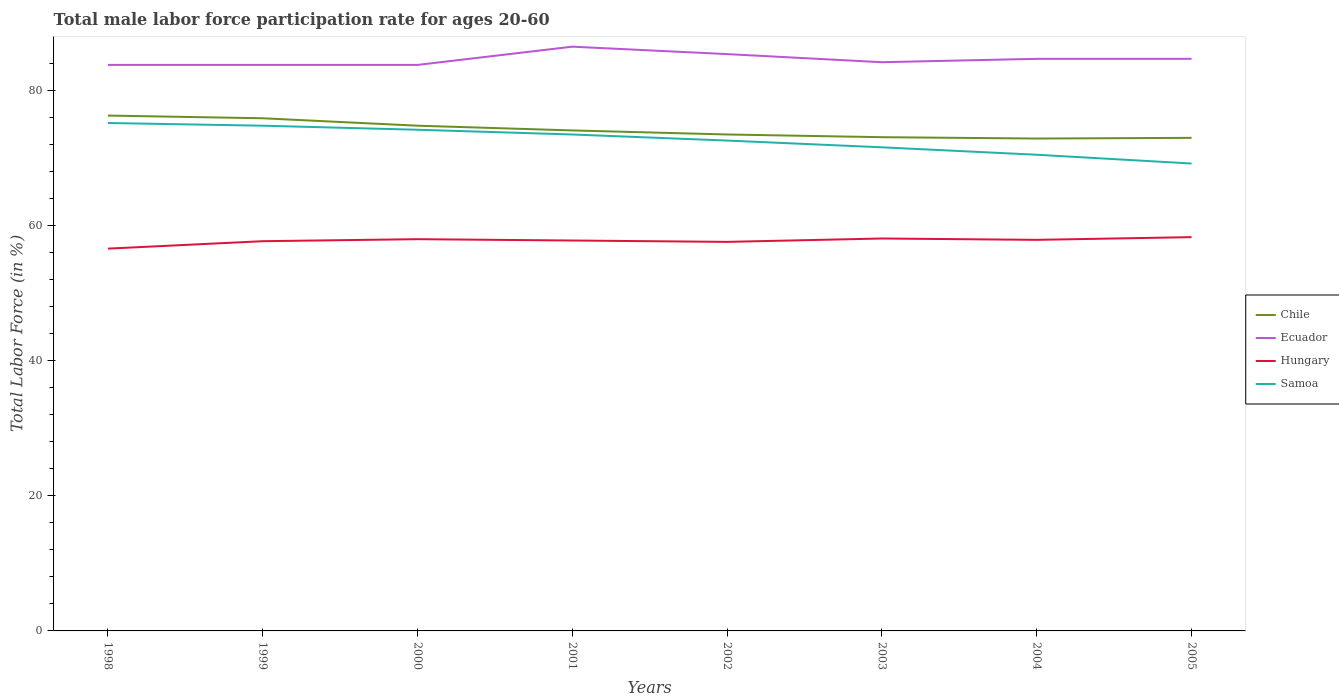Across all years, what is the maximum male labor force participation rate in Chile?
Your response must be concise. 72.9. What is the total male labor force participation rate in Chile in the graph?
Ensure brevity in your answer.  0.6. What is the difference between the highest and the second highest male labor force participation rate in Ecuador?
Ensure brevity in your answer.  2.7. Is the male labor force participation rate in Chile strictly greater than the male labor force participation rate in Hungary over the years?
Keep it short and to the point. No. How many years are there in the graph?
Ensure brevity in your answer.  8. What is the difference between two consecutive major ticks on the Y-axis?
Your response must be concise. 20. Are the values on the major ticks of Y-axis written in scientific E-notation?
Ensure brevity in your answer.  No. Does the graph contain grids?
Your answer should be compact. No. Where does the legend appear in the graph?
Keep it short and to the point. Center right. What is the title of the graph?
Give a very brief answer. Total male labor force participation rate for ages 20-60. Does "Chad" appear as one of the legend labels in the graph?
Offer a terse response. No. What is the label or title of the X-axis?
Make the answer very short. Years. What is the Total Labor Force (in %) of Chile in 1998?
Keep it short and to the point. 76.3. What is the Total Labor Force (in %) of Ecuador in 1998?
Make the answer very short. 83.8. What is the Total Labor Force (in %) of Hungary in 1998?
Offer a very short reply. 56.6. What is the Total Labor Force (in %) of Samoa in 1998?
Keep it short and to the point. 75.2. What is the Total Labor Force (in %) in Chile in 1999?
Provide a short and direct response. 75.9. What is the Total Labor Force (in %) of Ecuador in 1999?
Your answer should be very brief. 83.8. What is the Total Labor Force (in %) of Hungary in 1999?
Offer a terse response. 57.7. What is the Total Labor Force (in %) of Samoa in 1999?
Offer a very short reply. 74.8. What is the Total Labor Force (in %) in Chile in 2000?
Give a very brief answer. 74.8. What is the Total Labor Force (in %) in Ecuador in 2000?
Make the answer very short. 83.8. What is the Total Labor Force (in %) of Hungary in 2000?
Your answer should be very brief. 58. What is the Total Labor Force (in %) in Samoa in 2000?
Make the answer very short. 74.2. What is the Total Labor Force (in %) of Chile in 2001?
Provide a short and direct response. 74.1. What is the Total Labor Force (in %) of Ecuador in 2001?
Make the answer very short. 86.5. What is the Total Labor Force (in %) of Hungary in 2001?
Provide a succinct answer. 57.8. What is the Total Labor Force (in %) in Samoa in 2001?
Provide a short and direct response. 73.5. What is the Total Labor Force (in %) in Chile in 2002?
Provide a short and direct response. 73.5. What is the Total Labor Force (in %) in Ecuador in 2002?
Keep it short and to the point. 85.4. What is the Total Labor Force (in %) of Hungary in 2002?
Keep it short and to the point. 57.6. What is the Total Labor Force (in %) in Samoa in 2002?
Your response must be concise. 72.6. What is the Total Labor Force (in %) of Chile in 2003?
Offer a very short reply. 73.1. What is the Total Labor Force (in %) of Ecuador in 2003?
Ensure brevity in your answer.  84.2. What is the Total Labor Force (in %) in Hungary in 2003?
Offer a terse response. 58.1. What is the Total Labor Force (in %) of Samoa in 2003?
Ensure brevity in your answer.  71.6. What is the Total Labor Force (in %) in Chile in 2004?
Your answer should be compact. 72.9. What is the Total Labor Force (in %) in Ecuador in 2004?
Ensure brevity in your answer.  84.7. What is the Total Labor Force (in %) in Hungary in 2004?
Give a very brief answer. 57.9. What is the Total Labor Force (in %) in Samoa in 2004?
Keep it short and to the point. 70.5. What is the Total Labor Force (in %) of Chile in 2005?
Your response must be concise. 73. What is the Total Labor Force (in %) in Ecuador in 2005?
Provide a succinct answer. 84.7. What is the Total Labor Force (in %) of Hungary in 2005?
Keep it short and to the point. 58.3. What is the Total Labor Force (in %) of Samoa in 2005?
Your response must be concise. 69.2. Across all years, what is the maximum Total Labor Force (in %) in Chile?
Provide a succinct answer. 76.3. Across all years, what is the maximum Total Labor Force (in %) of Ecuador?
Your response must be concise. 86.5. Across all years, what is the maximum Total Labor Force (in %) in Hungary?
Give a very brief answer. 58.3. Across all years, what is the maximum Total Labor Force (in %) in Samoa?
Offer a very short reply. 75.2. Across all years, what is the minimum Total Labor Force (in %) of Chile?
Offer a terse response. 72.9. Across all years, what is the minimum Total Labor Force (in %) of Ecuador?
Offer a terse response. 83.8. Across all years, what is the minimum Total Labor Force (in %) in Hungary?
Offer a very short reply. 56.6. Across all years, what is the minimum Total Labor Force (in %) in Samoa?
Ensure brevity in your answer.  69.2. What is the total Total Labor Force (in %) of Chile in the graph?
Your answer should be very brief. 593.6. What is the total Total Labor Force (in %) of Ecuador in the graph?
Make the answer very short. 676.9. What is the total Total Labor Force (in %) of Hungary in the graph?
Ensure brevity in your answer.  462. What is the total Total Labor Force (in %) in Samoa in the graph?
Provide a succinct answer. 581.6. What is the difference between the Total Labor Force (in %) in Chile in 1998 and that in 1999?
Ensure brevity in your answer.  0.4. What is the difference between the Total Labor Force (in %) of Ecuador in 1998 and that in 1999?
Provide a short and direct response. 0. What is the difference between the Total Labor Force (in %) in Hungary in 1998 and that in 1999?
Provide a short and direct response. -1.1. What is the difference between the Total Labor Force (in %) of Samoa in 1998 and that in 1999?
Keep it short and to the point. 0.4. What is the difference between the Total Labor Force (in %) of Hungary in 1998 and that in 2000?
Provide a short and direct response. -1.4. What is the difference between the Total Labor Force (in %) in Samoa in 1998 and that in 2000?
Ensure brevity in your answer.  1. What is the difference between the Total Labor Force (in %) in Hungary in 1998 and that in 2002?
Your answer should be compact. -1. What is the difference between the Total Labor Force (in %) of Ecuador in 1998 and that in 2003?
Keep it short and to the point. -0.4. What is the difference between the Total Labor Force (in %) of Samoa in 1998 and that in 2003?
Make the answer very short. 3.6. What is the difference between the Total Labor Force (in %) in Chile in 1998 and that in 2004?
Make the answer very short. 3.4. What is the difference between the Total Labor Force (in %) in Hungary in 1998 and that in 2004?
Offer a terse response. -1.3. What is the difference between the Total Labor Force (in %) in Chile in 1998 and that in 2005?
Give a very brief answer. 3.3. What is the difference between the Total Labor Force (in %) in Ecuador in 1998 and that in 2005?
Give a very brief answer. -0.9. What is the difference between the Total Labor Force (in %) of Samoa in 1998 and that in 2005?
Provide a succinct answer. 6. What is the difference between the Total Labor Force (in %) in Ecuador in 1999 and that in 2000?
Offer a very short reply. 0. What is the difference between the Total Labor Force (in %) in Hungary in 1999 and that in 2000?
Your answer should be very brief. -0.3. What is the difference between the Total Labor Force (in %) of Samoa in 1999 and that in 2000?
Ensure brevity in your answer.  0.6. What is the difference between the Total Labor Force (in %) of Ecuador in 1999 and that in 2001?
Your answer should be very brief. -2.7. What is the difference between the Total Labor Force (in %) in Hungary in 1999 and that in 2001?
Your answer should be compact. -0.1. What is the difference between the Total Labor Force (in %) in Samoa in 1999 and that in 2001?
Offer a terse response. 1.3. What is the difference between the Total Labor Force (in %) in Chile in 1999 and that in 2002?
Your answer should be very brief. 2.4. What is the difference between the Total Labor Force (in %) in Ecuador in 1999 and that in 2002?
Make the answer very short. -1.6. What is the difference between the Total Labor Force (in %) in Samoa in 1999 and that in 2002?
Provide a succinct answer. 2.2. What is the difference between the Total Labor Force (in %) in Samoa in 1999 and that in 2003?
Give a very brief answer. 3.2. What is the difference between the Total Labor Force (in %) of Ecuador in 1999 and that in 2004?
Offer a terse response. -0.9. What is the difference between the Total Labor Force (in %) in Samoa in 1999 and that in 2004?
Provide a short and direct response. 4.3. What is the difference between the Total Labor Force (in %) of Chile in 1999 and that in 2005?
Your response must be concise. 2.9. What is the difference between the Total Labor Force (in %) of Ecuador in 1999 and that in 2005?
Offer a terse response. -0.9. What is the difference between the Total Labor Force (in %) in Samoa in 1999 and that in 2005?
Ensure brevity in your answer.  5.6. What is the difference between the Total Labor Force (in %) in Samoa in 2000 and that in 2001?
Your response must be concise. 0.7. What is the difference between the Total Labor Force (in %) in Chile in 2000 and that in 2002?
Your answer should be very brief. 1.3. What is the difference between the Total Labor Force (in %) in Ecuador in 2000 and that in 2002?
Offer a terse response. -1.6. What is the difference between the Total Labor Force (in %) in Samoa in 2000 and that in 2002?
Provide a short and direct response. 1.6. What is the difference between the Total Labor Force (in %) of Hungary in 2000 and that in 2003?
Your response must be concise. -0.1. What is the difference between the Total Labor Force (in %) in Samoa in 2000 and that in 2003?
Make the answer very short. 2.6. What is the difference between the Total Labor Force (in %) in Chile in 2000 and that in 2004?
Your answer should be compact. 1.9. What is the difference between the Total Labor Force (in %) of Hungary in 2000 and that in 2004?
Your answer should be very brief. 0.1. What is the difference between the Total Labor Force (in %) of Chile in 2000 and that in 2005?
Ensure brevity in your answer.  1.8. What is the difference between the Total Labor Force (in %) of Hungary in 2000 and that in 2005?
Ensure brevity in your answer.  -0.3. What is the difference between the Total Labor Force (in %) in Samoa in 2000 and that in 2005?
Give a very brief answer. 5. What is the difference between the Total Labor Force (in %) in Chile in 2001 and that in 2002?
Give a very brief answer. 0.6. What is the difference between the Total Labor Force (in %) of Hungary in 2001 and that in 2002?
Give a very brief answer. 0.2. What is the difference between the Total Labor Force (in %) of Ecuador in 2001 and that in 2003?
Your response must be concise. 2.3. What is the difference between the Total Labor Force (in %) in Samoa in 2001 and that in 2003?
Provide a succinct answer. 1.9. What is the difference between the Total Labor Force (in %) in Chile in 2001 and that in 2005?
Your answer should be compact. 1.1. What is the difference between the Total Labor Force (in %) in Ecuador in 2001 and that in 2005?
Your answer should be compact. 1.8. What is the difference between the Total Labor Force (in %) in Chile in 2002 and that in 2003?
Make the answer very short. 0.4. What is the difference between the Total Labor Force (in %) in Ecuador in 2002 and that in 2003?
Provide a short and direct response. 1.2. What is the difference between the Total Labor Force (in %) of Hungary in 2002 and that in 2003?
Provide a short and direct response. -0.5. What is the difference between the Total Labor Force (in %) in Hungary in 2002 and that in 2004?
Provide a short and direct response. -0.3. What is the difference between the Total Labor Force (in %) in Samoa in 2002 and that in 2004?
Offer a terse response. 2.1. What is the difference between the Total Labor Force (in %) of Ecuador in 2002 and that in 2005?
Your answer should be very brief. 0.7. What is the difference between the Total Labor Force (in %) in Samoa in 2002 and that in 2005?
Provide a succinct answer. 3.4. What is the difference between the Total Labor Force (in %) of Chile in 2003 and that in 2004?
Make the answer very short. 0.2. What is the difference between the Total Labor Force (in %) of Samoa in 2003 and that in 2004?
Offer a terse response. 1.1. What is the difference between the Total Labor Force (in %) of Hungary in 2003 and that in 2005?
Make the answer very short. -0.2. What is the difference between the Total Labor Force (in %) of Samoa in 2003 and that in 2005?
Your answer should be compact. 2.4. What is the difference between the Total Labor Force (in %) of Hungary in 2004 and that in 2005?
Provide a succinct answer. -0.4. What is the difference between the Total Labor Force (in %) in Chile in 1998 and the Total Labor Force (in %) in Hungary in 1999?
Make the answer very short. 18.6. What is the difference between the Total Labor Force (in %) in Chile in 1998 and the Total Labor Force (in %) in Samoa in 1999?
Offer a terse response. 1.5. What is the difference between the Total Labor Force (in %) in Ecuador in 1998 and the Total Labor Force (in %) in Hungary in 1999?
Provide a short and direct response. 26.1. What is the difference between the Total Labor Force (in %) in Ecuador in 1998 and the Total Labor Force (in %) in Samoa in 1999?
Provide a short and direct response. 9. What is the difference between the Total Labor Force (in %) in Hungary in 1998 and the Total Labor Force (in %) in Samoa in 1999?
Make the answer very short. -18.2. What is the difference between the Total Labor Force (in %) in Chile in 1998 and the Total Labor Force (in %) in Hungary in 2000?
Your response must be concise. 18.3. What is the difference between the Total Labor Force (in %) of Chile in 1998 and the Total Labor Force (in %) of Samoa in 2000?
Your answer should be very brief. 2.1. What is the difference between the Total Labor Force (in %) of Ecuador in 1998 and the Total Labor Force (in %) of Hungary in 2000?
Ensure brevity in your answer.  25.8. What is the difference between the Total Labor Force (in %) in Hungary in 1998 and the Total Labor Force (in %) in Samoa in 2000?
Offer a very short reply. -17.6. What is the difference between the Total Labor Force (in %) of Chile in 1998 and the Total Labor Force (in %) of Hungary in 2001?
Your answer should be compact. 18.5. What is the difference between the Total Labor Force (in %) of Hungary in 1998 and the Total Labor Force (in %) of Samoa in 2001?
Keep it short and to the point. -16.9. What is the difference between the Total Labor Force (in %) of Chile in 1998 and the Total Labor Force (in %) of Ecuador in 2002?
Offer a terse response. -9.1. What is the difference between the Total Labor Force (in %) in Chile in 1998 and the Total Labor Force (in %) in Samoa in 2002?
Provide a short and direct response. 3.7. What is the difference between the Total Labor Force (in %) in Ecuador in 1998 and the Total Labor Force (in %) in Hungary in 2002?
Make the answer very short. 26.2. What is the difference between the Total Labor Force (in %) in Ecuador in 1998 and the Total Labor Force (in %) in Samoa in 2002?
Offer a very short reply. 11.2. What is the difference between the Total Labor Force (in %) of Hungary in 1998 and the Total Labor Force (in %) of Samoa in 2002?
Offer a very short reply. -16. What is the difference between the Total Labor Force (in %) of Chile in 1998 and the Total Labor Force (in %) of Samoa in 2003?
Provide a succinct answer. 4.7. What is the difference between the Total Labor Force (in %) in Ecuador in 1998 and the Total Labor Force (in %) in Hungary in 2003?
Make the answer very short. 25.7. What is the difference between the Total Labor Force (in %) in Chile in 1998 and the Total Labor Force (in %) in Hungary in 2004?
Keep it short and to the point. 18.4. What is the difference between the Total Labor Force (in %) in Ecuador in 1998 and the Total Labor Force (in %) in Hungary in 2004?
Ensure brevity in your answer.  25.9. What is the difference between the Total Labor Force (in %) of Hungary in 1998 and the Total Labor Force (in %) of Samoa in 2004?
Provide a succinct answer. -13.9. What is the difference between the Total Labor Force (in %) of Chile in 1998 and the Total Labor Force (in %) of Ecuador in 2005?
Offer a terse response. -8.4. What is the difference between the Total Labor Force (in %) of Chile in 1998 and the Total Labor Force (in %) of Hungary in 2005?
Provide a succinct answer. 18. What is the difference between the Total Labor Force (in %) of Chile in 1998 and the Total Labor Force (in %) of Samoa in 2005?
Give a very brief answer. 7.1. What is the difference between the Total Labor Force (in %) of Hungary in 1998 and the Total Labor Force (in %) of Samoa in 2005?
Make the answer very short. -12.6. What is the difference between the Total Labor Force (in %) in Chile in 1999 and the Total Labor Force (in %) in Ecuador in 2000?
Provide a short and direct response. -7.9. What is the difference between the Total Labor Force (in %) in Chile in 1999 and the Total Labor Force (in %) in Hungary in 2000?
Offer a very short reply. 17.9. What is the difference between the Total Labor Force (in %) of Chile in 1999 and the Total Labor Force (in %) of Samoa in 2000?
Your response must be concise. 1.7. What is the difference between the Total Labor Force (in %) in Ecuador in 1999 and the Total Labor Force (in %) in Hungary in 2000?
Your answer should be compact. 25.8. What is the difference between the Total Labor Force (in %) in Hungary in 1999 and the Total Labor Force (in %) in Samoa in 2000?
Your response must be concise. -16.5. What is the difference between the Total Labor Force (in %) of Chile in 1999 and the Total Labor Force (in %) of Ecuador in 2001?
Keep it short and to the point. -10.6. What is the difference between the Total Labor Force (in %) of Chile in 1999 and the Total Labor Force (in %) of Hungary in 2001?
Keep it short and to the point. 18.1. What is the difference between the Total Labor Force (in %) in Chile in 1999 and the Total Labor Force (in %) in Samoa in 2001?
Offer a very short reply. 2.4. What is the difference between the Total Labor Force (in %) in Hungary in 1999 and the Total Labor Force (in %) in Samoa in 2001?
Make the answer very short. -15.8. What is the difference between the Total Labor Force (in %) in Ecuador in 1999 and the Total Labor Force (in %) in Hungary in 2002?
Keep it short and to the point. 26.2. What is the difference between the Total Labor Force (in %) in Ecuador in 1999 and the Total Labor Force (in %) in Samoa in 2002?
Offer a terse response. 11.2. What is the difference between the Total Labor Force (in %) in Hungary in 1999 and the Total Labor Force (in %) in Samoa in 2002?
Provide a short and direct response. -14.9. What is the difference between the Total Labor Force (in %) in Chile in 1999 and the Total Labor Force (in %) in Samoa in 2003?
Your answer should be compact. 4.3. What is the difference between the Total Labor Force (in %) in Ecuador in 1999 and the Total Labor Force (in %) in Hungary in 2003?
Provide a succinct answer. 25.7. What is the difference between the Total Labor Force (in %) in Chile in 1999 and the Total Labor Force (in %) in Hungary in 2004?
Ensure brevity in your answer.  18. What is the difference between the Total Labor Force (in %) in Ecuador in 1999 and the Total Labor Force (in %) in Hungary in 2004?
Provide a succinct answer. 25.9. What is the difference between the Total Labor Force (in %) in Chile in 1999 and the Total Labor Force (in %) in Hungary in 2005?
Make the answer very short. 17.6. What is the difference between the Total Labor Force (in %) of Chile in 2000 and the Total Labor Force (in %) of Hungary in 2001?
Your response must be concise. 17. What is the difference between the Total Labor Force (in %) in Chile in 2000 and the Total Labor Force (in %) in Samoa in 2001?
Make the answer very short. 1.3. What is the difference between the Total Labor Force (in %) in Ecuador in 2000 and the Total Labor Force (in %) in Hungary in 2001?
Keep it short and to the point. 26. What is the difference between the Total Labor Force (in %) in Hungary in 2000 and the Total Labor Force (in %) in Samoa in 2001?
Make the answer very short. -15.5. What is the difference between the Total Labor Force (in %) of Chile in 2000 and the Total Labor Force (in %) of Hungary in 2002?
Offer a terse response. 17.2. What is the difference between the Total Labor Force (in %) of Ecuador in 2000 and the Total Labor Force (in %) of Hungary in 2002?
Offer a terse response. 26.2. What is the difference between the Total Labor Force (in %) of Ecuador in 2000 and the Total Labor Force (in %) of Samoa in 2002?
Your response must be concise. 11.2. What is the difference between the Total Labor Force (in %) of Hungary in 2000 and the Total Labor Force (in %) of Samoa in 2002?
Your answer should be compact. -14.6. What is the difference between the Total Labor Force (in %) of Chile in 2000 and the Total Labor Force (in %) of Hungary in 2003?
Give a very brief answer. 16.7. What is the difference between the Total Labor Force (in %) of Ecuador in 2000 and the Total Labor Force (in %) of Hungary in 2003?
Give a very brief answer. 25.7. What is the difference between the Total Labor Force (in %) of Chile in 2000 and the Total Labor Force (in %) of Samoa in 2004?
Provide a short and direct response. 4.3. What is the difference between the Total Labor Force (in %) in Ecuador in 2000 and the Total Labor Force (in %) in Hungary in 2004?
Provide a succinct answer. 25.9. What is the difference between the Total Labor Force (in %) of Chile in 2000 and the Total Labor Force (in %) of Ecuador in 2005?
Ensure brevity in your answer.  -9.9. What is the difference between the Total Labor Force (in %) of Chile in 2000 and the Total Labor Force (in %) of Samoa in 2005?
Provide a short and direct response. 5.6. What is the difference between the Total Labor Force (in %) of Ecuador in 2000 and the Total Labor Force (in %) of Samoa in 2005?
Make the answer very short. 14.6. What is the difference between the Total Labor Force (in %) in Chile in 2001 and the Total Labor Force (in %) in Hungary in 2002?
Offer a very short reply. 16.5. What is the difference between the Total Labor Force (in %) in Chile in 2001 and the Total Labor Force (in %) in Samoa in 2002?
Give a very brief answer. 1.5. What is the difference between the Total Labor Force (in %) of Ecuador in 2001 and the Total Labor Force (in %) of Hungary in 2002?
Make the answer very short. 28.9. What is the difference between the Total Labor Force (in %) of Hungary in 2001 and the Total Labor Force (in %) of Samoa in 2002?
Make the answer very short. -14.8. What is the difference between the Total Labor Force (in %) of Chile in 2001 and the Total Labor Force (in %) of Samoa in 2003?
Ensure brevity in your answer.  2.5. What is the difference between the Total Labor Force (in %) of Ecuador in 2001 and the Total Labor Force (in %) of Hungary in 2003?
Your answer should be very brief. 28.4. What is the difference between the Total Labor Force (in %) of Hungary in 2001 and the Total Labor Force (in %) of Samoa in 2003?
Keep it short and to the point. -13.8. What is the difference between the Total Labor Force (in %) in Chile in 2001 and the Total Labor Force (in %) in Ecuador in 2004?
Keep it short and to the point. -10.6. What is the difference between the Total Labor Force (in %) in Chile in 2001 and the Total Labor Force (in %) in Samoa in 2004?
Ensure brevity in your answer.  3.6. What is the difference between the Total Labor Force (in %) in Ecuador in 2001 and the Total Labor Force (in %) in Hungary in 2004?
Your response must be concise. 28.6. What is the difference between the Total Labor Force (in %) in Ecuador in 2001 and the Total Labor Force (in %) in Hungary in 2005?
Offer a very short reply. 28.2. What is the difference between the Total Labor Force (in %) of Chile in 2002 and the Total Labor Force (in %) of Ecuador in 2003?
Your answer should be very brief. -10.7. What is the difference between the Total Labor Force (in %) of Chile in 2002 and the Total Labor Force (in %) of Samoa in 2003?
Offer a terse response. 1.9. What is the difference between the Total Labor Force (in %) in Ecuador in 2002 and the Total Labor Force (in %) in Hungary in 2003?
Offer a very short reply. 27.3. What is the difference between the Total Labor Force (in %) in Hungary in 2002 and the Total Labor Force (in %) in Samoa in 2003?
Offer a very short reply. -14. What is the difference between the Total Labor Force (in %) of Chile in 2002 and the Total Labor Force (in %) of Hungary in 2004?
Your response must be concise. 15.6. What is the difference between the Total Labor Force (in %) of Chile in 2002 and the Total Labor Force (in %) of Samoa in 2004?
Offer a terse response. 3. What is the difference between the Total Labor Force (in %) of Ecuador in 2002 and the Total Labor Force (in %) of Hungary in 2004?
Your response must be concise. 27.5. What is the difference between the Total Labor Force (in %) in Ecuador in 2002 and the Total Labor Force (in %) in Samoa in 2004?
Offer a terse response. 14.9. What is the difference between the Total Labor Force (in %) of Chile in 2002 and the Total Labor Force (in %) of Ecuador in 2005?
Keep it short and to the point. -11.2. What is the difference between the Total Labor Force (in %) of Chile in 2002 and the Total Labor Force (in %) of Samoa in 2005?
Keep it short and to the point. 4.3. What is the difference between the Total Labor Force (in %) of Ecuador in 2002 and the Total Labor Force (in %) of Hungary in 2005?
Provide a succinct answer. 27.1. What is the difference between the Total Labor Force (in %) in Hungary in 2002 and the Total Labor Force (in %) in Samoa in 2005?
Offer a terse response. -11.6. What is the difference between the Total Labor Force (in %) of Chile in 2003 and the Total Labor Force (in %) of Ecuador in 2004?
Give a very brief answer. -11.6. What is the difference between the Total Labor Force (in %) in Chile in 2003 and the Total Labor Force (in %) in Samoa in 2004?
Make the answer very short. 2.6. What is the difference between the Total Labor Force (in %) in Ecuador in 2003 and the Total Labor Force (in %) in Hungary in 2004?
Ensure brevity in your answer.  26.3. What is the difference between the Total Labor Force (in %) in Hungary in 2003 and the Total Labor Force (in %) in Samoa in 2004?
Your response must be concise. -12.4. What is the difference between the Total Labor Force (in %) in Ecuador in 2003 and the Total Labor Force (in %) in Hungary in 2005?
Provide a succinct answer. 25.9. What is the difference between the Total Labor Force (in %) in Ecuador in 2003 and the Total Labor Force (in %) in Samoa in 2005?
Offer a terse response. 15. What is the difference between the Total Labor Force (in %) in Chile in 2004 and the Total Labor Force (in %) in Hungary in 2005?
Provide a short and direct response. 14.6. What is the difference between the Total Labor Force (in %) of Chile in 2004 and the Total Labor Force (in %) of Samoa in 2005?
Ensure brevity in your answer.  3.7. What is the difference between the Total Labor Force (in %) in Ecuador in 2004 and the Total Labor Force (in %) in Hungary in 2005?
Keep it short and to the point. 26.4. What is the difference between the Total Labor Force (in %) of Hungary in 2004 and the Total Labor Force (in %) of Samoa in 2005?
Give a very brief answer. -11.3. What is the average Total Labor Force (in %) of Chile per year?
Keep it short and to the point. 74.2. What is the average Total Labor Force (in %) of Ecuador per year?
Provide a succinct answer. 84.61. What is the average Total Labor Force (in %) of Hungary per year?
Your answer should be very brief. 57.75. What is the average Total Labor Force (in %) of Samoa per year?
Offer a very short reply. 72.7. In the year 1998, what is the difference between the Total Labor Force (in %) of Chile and Total Labor Force (in %) of Hungary?
Make the answer very short. 19.7. In the year 1998, what is the difference between the Total Labor Force (in %) of Chile and Total Labor Force (in %) of Samoa?
Give a very brief answer. 1.1. In the year 1998, what is the difference between the Total Labor Force (in %) of Ecuador and Total Labor Force (in %) of Hungary?
Give a very brief answer. 27.2. In the year 1998, what is the difference between the Total Labor Force (in %) in Hungary and Total Labor Force (in %) in Samoa?
Offer a very short reply. -18.6. In the year 1999, what is the difference between the Total Labor Force (in %) in Chile and Total Labor Force (in %) in Ecuador?
Your answer should be compact. -7.9. In the year 1999, what is the difference between the Total Labor Force (in %) of Ecuador and Total Labor Force (in %) of Hungary?
Provide a succinct answer. 26.1. In the year 1999, what is the difference between the Total Labor Force (in %) in Hungary and Total Labor Force (in %) in Samoa?
Provide a short and direct response. -17.1. In the year 2000, what is the difference between the Total Labor Force (in %) in Chile and Total Labor Force (in %) in Ecuador?
Make the answer very short. -9. In the year 2000, what is the difference between the Total Labor Force (in %) of Chile and Total Labor Force (in %) of Samoa?
Keep it short and to the point. 0.6. In the year 2000, what is the difference between the Total Labor Force (in %) of Ecuador and Total Labor Force (in %) of Hungary?
Ensure brevity in your answer.  25.8. In the year 2000, what is the difference between the Total Labor Force (in %) in Ecuador and Total Labor Force (in %) in Samoa?
Provide a succinct answer. 9.6. In the year 2000, what is the difference between the Total Labor Force (in %) in Hungary and Total Labor Force (in %) in Samoa?
Your answer should be very brief. -16.2. In the year 2001, what is the difference between the Total Labor Force (in %) in Chile and Total Labor Force (in %) in Hungary?
Give a very brief answer. 16.3. In the year 2001, what is the difference between the Total Labor Force (in %) of Ecuador and Total Labor Force (in %) of Hungary?
Your answer should be very brief. 28.7. In the year 2001, what is the difference between the Total Labor Force (in %) of Hungary and Total Labor Force (in %) of Samoa?
Give a very brief answer. -15.7. In the year 2002, what is the difference between the Total Labor Force (in %) of Chile and Total Labor Force (in %) of Ecuador?
Make the answer very short. -11.9. In the year 2002, what is the difference between the Total Labor Force (in %) of Chile and Total Labor Force (in %) of Samoa?
Give a very brief answer. 0.9. In the year 2002, what is the difference between the Total Labor Force (in %) of Ecuador and Total Labor Force (in %) of Hungary?
Provide a succinct answer. 27.8. In the year 2002, what is the difference between the Total Labor Force (in %) of Hungary and Total Labor Force (in %) of Samoa?
Provide a succinct answer. -15. In the year 2003, what is the difference between the Total Labor Force (in %) of Chile and Total Labor Force (in %) of Hungary?
Give a very brief answer. 15. In the year 2003, what is the difference between the Total Labor Force (in %) of Ecuador and Total Labor Force (in %) of Hungary?
Offer a very short reply. 26.1. In the year 2003, what is the difference between the Total Labor Force (in %) in Ecuador and Total Labor Force (in %) in Samoa?
Provide a short and direct response. 12.6. In the year 2003, what is the difference between the Total Labor Force (in %) of Hungary and Total Labor Force (in %) of Samoa?
Provide a short and direct response. -13.5. In the year 2004, what is the difference between the Total Labor Force (in %) in Chile and Total Labor Force (in %) in Samoa?
Make the answer very short. 2.4. In the year 2004, what is the difference between the Total Labor Force (in %) in Ecuador and Total Labor Force (in %) in Hungary?
Offer a terse response. 26.8. In the year 2005, what is the difference between the Total Labor Force (in %) of Chile and Total Labor Force (in %) of Hungary?
Provide a short and direct response. 14.7. In the year 2005, what is the difference between the Total Labor Force (in %) in Chile and Total Labor Force (in %) in Samoa?
Your response must be concise. 3.8. In the year 2005, what is the difference between the Total Labor Force (in %) in Ecuador and Total Labor Force (in %) in Hungary?
Provide a succinct answer. 26.4. In the year 2005, what is the difference between the Total Labor Force (in %) of Ecuador and Total Labor Force (in %) of Samoa?
Offer a very short reply. 15.5. In the year 2005, what is the difference between the Total Labor Force (in %) in Hungary and Total Labor Force (in %) in Samoa?
Keep it short and to the point. -10.9. What is the ratio of the Total Labor Force (in %) in Chile in 1998 to that in 1999?
Ensure brevity in your answer.  1.01. What is the ratio of the Total Labor Force (in %) in Hungary in 1998 to that in 1999?
Offer a terse response. 0.98. What is the ratio of the Total Labor Force (in %) in Samoa in 1998 to that in 1999?
Your answer should be compact. 1.01. What is the ratio of the Total Labor Force (in %) of Chile in 1998 to that in 2000?
Your answer should be compact. 1.02. What is the ratio of the Total Labor Force (in %) of Hungary in 1998 to that in 2000?
Your answer should be compact. 0.98. What is the ratio of the Total Labor Force (in %) in Samoa in 1998 to that in 2000?
Your response must be concise. 1.01. What is the ratio of the Total Labor Force (in %) in Chile in 1998 to that in 2001?
Offer a terse response. 1.03. What is the ratio of the Total Labor Force (in %) of Ecuador in 1998 to that in 2001?
Offer a terse response. 0.97. What is the ratio of the Total Labor Force (in %) in Hungary in 1998 to that in 2001?
Your answer should be compact. 0.98. What is the ratio of the Total Labor Force (in %) in Samoa in 1998 to that in 2001?
Provide a short and direct response. 1.02. What is the ratio of the Total Labor Force (in %) of Chile in 1998 to that in 2002?
Offer a terse response. 1.04. What is the ratio of the Total Labor Force (in %) of Ecuador in 1998 to that in 2002?
Your answer should be very brief. 0.98. What is the ratio of the Total Labor Force (in %) in Hungary in 1998 to that in 2002?
Make the answer very short. 0.98. What is the ratio of the Total Labor Force (in %) of Samoa in 1998 to that in 2002?
Keep it short and to the point. 1.04. What is the ratio of the Total Labor Force (in %) in Chile in 1998 to that in 2003?
Your response must be concise. 1.04. What is the ratio of the Total Labor Force (in %) of Hungary in 1998 to that in 2003?
Offer a terse response. 0.97. What is the ratio of the Total Labor Force (in %) of Samoa in 1998 to that in 2003?
Make the answer very short. 1.05. What is the ratio of the Total Labor Force (in %) of Chile in 1998 to that in 2004?
Give a very brief answer. 1.05. What is the ratio of the Total Labor Force (in %) of Hungary in 1998 to that in 2004?
Offer a terse response. 0.98. What is the ratio of the Total Labor Force (in %) of Samoa in 1998 to that in 2004?
Provide a short and direct response. 1.07. What is the ratio of the Total Labor Force (in %) of Chile in 1998 to that in 2005?
Provide a succinct answer. 1.05. What is the ratio of the Total Labor Force (in %) in Hungary in 1998 to that in 2005?
Make the answer very short. 0.97. What is the ratio of the Total Labor Force (in %) of Samoa in 1998 to that in 2005?
Make the answer very short. 1.09. What is the ratio of the Total Labor Force (in %) in Chile in 1999 to that in 2000?
Make the answer very short. 1.01. What is the ratio of the Total Labor Force (in %) in Ecuador in 1999 to that in 2000?
Make the answer very short. 1. What is the ratio of the Total Labor Force (in %) of Hungary in 1999 to that in 2000?
Your answer should be very brief. 0.99. What is the ratio of the Total Labor Force (in %) in Samoa in 1999 to that in 2000?
Offer a very short reply. 1.01. What is the ratio of the Total Labor Force (in %) in Chile in 1999 to that in 2001?
Your response must be concise. 1.02. What is the ratio of the Total Labor Force (in %) in Ecuador in 1999 to that in 2001?
Your response must be concise. 0.97. What is the ratio of the Total Labor Force (in %) in Hungary in 1999 to that in 2001?
Ensure brevity in your answer.  1. What is the ratio of the Total Labor Force (in %) in Samoa in 1999 to that in 2001?
Make the answer very short. 1.02. What is the ratio of the Total Labor Force (in %) of Chile in 1999 to that in 2002?
Your answer should be very brief. 1.03. What is the ratio of the Total Labor Force (in %) of Ecuador in 1999 to that in 2002?
Offer a terse response. 0.98. What is the ratio of the Total Labor Force (in %) of Hungary in 1999 to that in 2002?
Make the answer very short. 1. What is the ratio of the Total Labor Force (in %) of Samoa in 1999 to that in 2002?
Make the answer very short. 1.03. What is the ratio of the Total Labor Force (in %) of Chile in 1999 to that in 2003?
Give a very brief answer. 1.04. What is the ratio of the Total Labor Force (in %) in Ecuador in 1999 to that in 2003?
Offer a very short reply. 1. What is the ratio of the Total Labor Force (in %) in Samoa in 1999 to that in 2003?
Ensure brevity in your answer.  1.04. What is the ratio of the Total Labor Force (in %) of Chile in 1999 to that in 2004?
Provide a succinct answer. 1.04. What is the ratio of the Total Labor Force (in %) in Ecuador in 1999 to that in 2004?
Make the answer very short. 0.99. What is the ratio of the Total Labor Force (in %) in Samoa in 1999 to that in 2004?
Offer a terse response. 1.06. What is the ratio of the Total Labor Force (in %) in Chile in 1999 to that in 2005?
Your response must be concise. 1.04. What is the ratio of the Total Labor Force (in %) of Samoa in 1999 to that in 2005?
Provide a short and direct response. 1.08. What is the ratio of the Total Labor Force (in %) of Chile in 2000 to that in 2001?
Give a very brief answer. 1.01. What is the ratio of the Total Labor Force (in %) of Ecuador in 2000 to that in 2001?
Give a very brief answer. 0.97. What is the ratio of the Total Labor Force (in %) in Hungary in 2000 to that in 2001?
Offer a very short reply. 1. What is the ratio of the Total Labor Force (in %) of Samoa in 2000 to that in 2001?
Provide a short and direct response. 1.01. What is the ratio of the Total Labor Force (in %) of Chile in 2000 to that in 2002?
Your answer should be very brief. 1.02. What is the ratio of the Total Labor Force (in %) of Ecuador in 2000 to that in 2002?
Your response must be concise. 0.98. What is the ratio of the Total Labor Force (in %) in Samoa in 2000 to that in 2002?
Provide a succinct answer. 1.02. What is the ratio of the Total Labor Force (in %) of Chile in 2000 to that in 2003?
Offer a terse response. 1.02. What is the ratio of the Total Labor Force (in %) of Ecuador in 2000 to that in 2003?
Keep it short and to the point. 1. What is the ratio of the Total Labor Force (in %) of Hungary in 2000 to that in 2003?
Provide a short and direct response. 1. What is the ratio of the Total Labor Force (in %) of Samoa in 2000 to that in 2003?
Your answer should be very brief. 1.04. What is the ratio of the Total Labor Force (in %) in Chile in 2000 to that in 2004?
Make the answer very short. 1.03. What is the ratio of the Total Labor Force (in %) in Ecuador in 2000 to that in 2004?
Offer a very short reply. 0.99. What is the ratio of the Total Labor Force (in %) in Samoa in 2000 to that in 2004?
Provide a short and direct response. 1.05. What is the ratio of the Total Labor Force (in %) of Chile in 2000 to that in 2005?
Provide a succinct answer. 1.02. What is the ratio of the Total Labor Force (in %) of Ecuador in 2000 to that in 2005?
Give a very brief answer. 0.99. What is the ratio of the Total Labor Force (in %) of Samoa in 2000 to that in 2005?
Ensure brevity in your answer.  1.07. What is the ratio of the Total Labor Force (in %) of Chile in 2001 to that in 2002?
Offer a very short reply. 1.01. What is the ratio of the Total Labor Force (in %) in Ecuador in 2001 to that in 2002?
Provide a short and direct response. 1.01. What is the ratio of the Total Labor Force (in %) in Hungary in 2001 to that in 2002?
Your answer should be very brief. 1. What is the ratio of the Total Labor Force (in %) of Samoa in 2001 to that in 2002?
Ensure brevity in your answer.  1.01. What is the ratio of the Total Labor Force (in %) of Chile in 2001 to that in 2003?
Offer a terse response. 1.01. What is the ratio of the Total Labor Force (in %) in Ecuador in 2001 to that in 2003?
Provide a succinct answer. 1.03. What is the ratio of the Total Labor Force (in %) in Hungary in 2001 to that in 2003?
Provide a succinct answer. 0.99. What is the ratio of the Total Labor Force (in %) of Samoa in 2001 to that in 2003?
Offer a terse response. 1.03. What is the ratio of the Total Labor Force (in %) of Chile in 2001 to that in 2004?
Offer a terse response. 1.02. What is the ratio of the Total Labor Force (in %) of Ecuador in 2001 to that in 2004?
Your answer should be compact. 1.02. What is the ratio of the Total Labor Force (in %) of Samoa in 2001 to that in 2004?
Provide a succinct answer. 1.04. What is the ratio of the Total Labor Force (in %) in Chile in 2001 to that in 2005?
Make the answer very short. 1.02. What is the ratio of the Total Labor Force (in %) of Ecuador in 2001 to that in 2005?
Ensure brevity in your answer.  1.02. What is the ratio of the Total Labor Force (in %) of Samoa in 2001 to that in 2005?
Your response must be concise. 1.06. What is the ratio of the Total Labor Force (in %) of Ecuador in 2002 to that in 2003?
Your answer should be very brief. 1.01. What is the ratio of the Total Labor Force (in %) in Chile in 2002 to that in 2004?
Keep it short and to the point. 1.01. What is the ratio of the Total Labor Force (in %) of Ecuador in 2002 to that in 2004?
Make the answer very short. 1.01. What is the ratio of the Total Labor Force (in %) of Samoa in 2002 to that in 2004?
Your answer should be very brief. 1.03. What is the ratio of the Total Labor Force (in %) of Chile in 2002 to that in 2005?
Make the answer very short. 1.01. What is the ratio of the Total Labor Force (in %) in Ecuador in 2002 to that in 2005?
Your answer should be compact. 1.01. What is the ratio of the Total Labor Force (in %) in Samoa in 2002 to that in 2005?
Your response must be concise. 1.05. What is the ratio of the Total Labor Force (in %) of Chile in 2003 to that in 2004?
Keep it short and to the point. 1. What is the ratio of the Total Labor Force (in %) in Samoa in 2003 to that in 2004?
Offer a very short reply. 1.02. What is the ratio of the Total Labor Force (in %) in Samoa in 2003 to that in 2005?
Provide a short and direct response. 1.03. What is the ratio of the Total Labor Force (in %) of Samoa in 2004 to that in 2005?
Provide a short and direct response. 1.02. What is the difference between the highest and the second highest Total Labor Force (in %) in Chile?
Provide a short and direct response. 0.4. What is the difference between the highest and the second highest Total Labor Force (in %) of Ecuador?
Your answer should be compact. 1.1. What is the difference between the highest and the second highest Total Labor Force (in %) of Hungary?
Offer a terse response. 0.2. What is the difference between the highest and the second highest Total Labor Force (in %) in Samoa?
Your response must be concise. 0.4. 